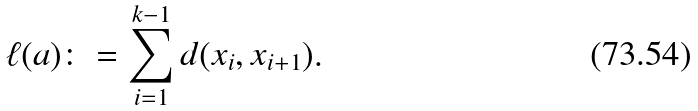Convert formula to latex. <formula><loc_0><loc_0><loc_500><loc_500>\ell ( a ) \colon = \sum _ { i = 1 } ^ { k - 1 } d ( x _ { i } , x _ { i + 1 } ) .</formula> 